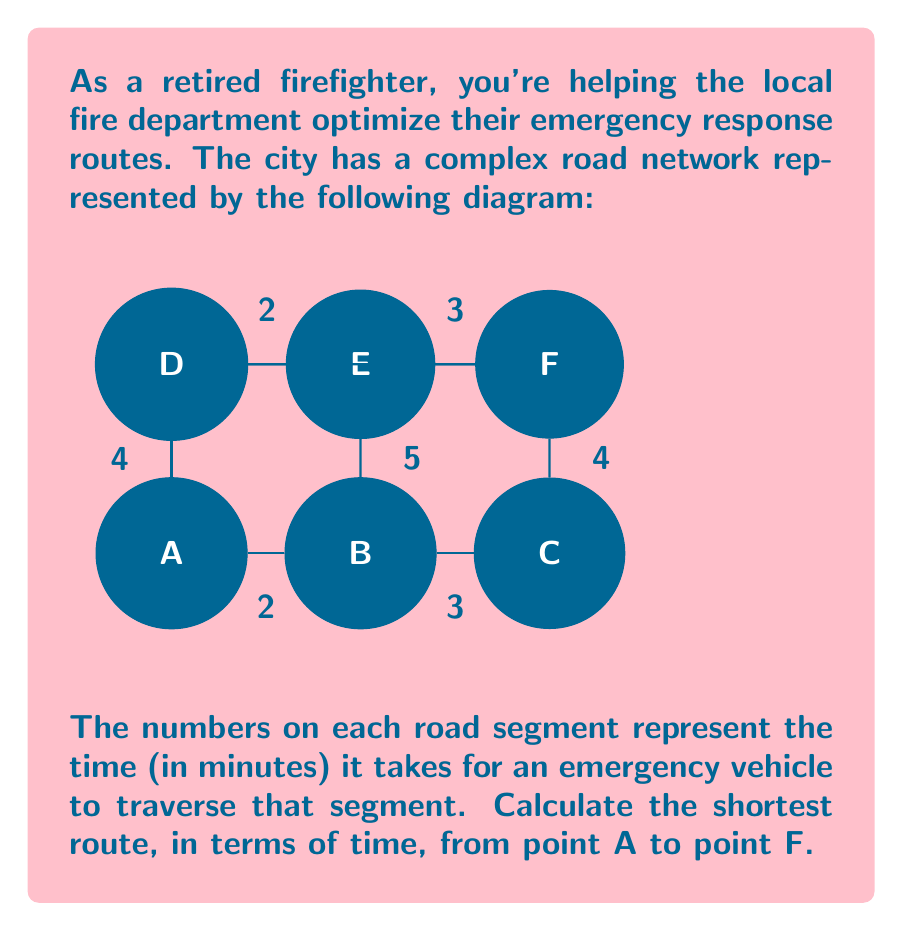Can you answer this question? To solve this problem, we'll use Dijkstra's algorithm, which is an efficient method for finding the shortest path in a weighted graph. Here's a step-by-step explanation:

1) Initialize:
   - Set distance to A as 0 and all other nodes as infinity.
   - Set all nodes as unvisited.

2) For the current node (starting with A), consider all unvisited neighbors and calculate their tentative distances.
   - A to B: 0 + 2 = 2
   - A to D: 0 + 4 = 4

3) Mark A as visited. B has the smallest tentative distance, so we move to B.

4) Update distances from B:
   - B to C: 2 + 3 = 5
   - B to E: 2 + 5 = 7

5) Mark B as visited. D has the smallest tentative distance among unvisited nodes, so we move to D.

6) Update distances from D:
   - D to E: 4 + 2 = 6
   - D to F: 4 + 6 = 10

7) Mark D as visited. C has the smallest tentative distance (5) among unvisited nodes, so we move to C.

8) Update distance from C:
   - C to F: 5 + 4 = 9

9) Mark C as visited. E has the smallest tentative distance (6) among unvisited nodes, so we move to E.

10) Update distance from E:
    - E to F: 6 + 3 = 9

11) Mark E as visited. F is the only unvisited node left, with a distance of 9.

The shortest path from A to F is A → B → C → F, with a total time of 9 minutes.
Answer: A → B → C → F, 9 minutes 